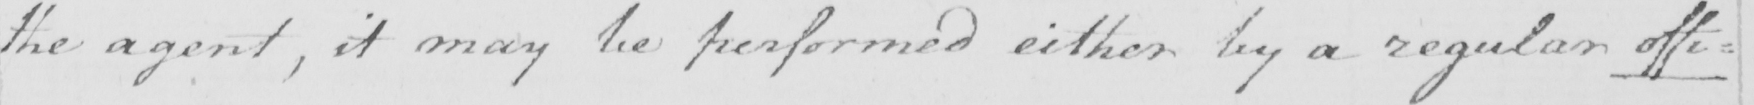Please transcribe the handwritten text in this image. the agent , it may be perfomed either by a regular offi= 